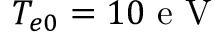<formula> <loc_0><loc_0><loc_500><loc_500>T _ { e 0 } = 1 0 e V</formula> 